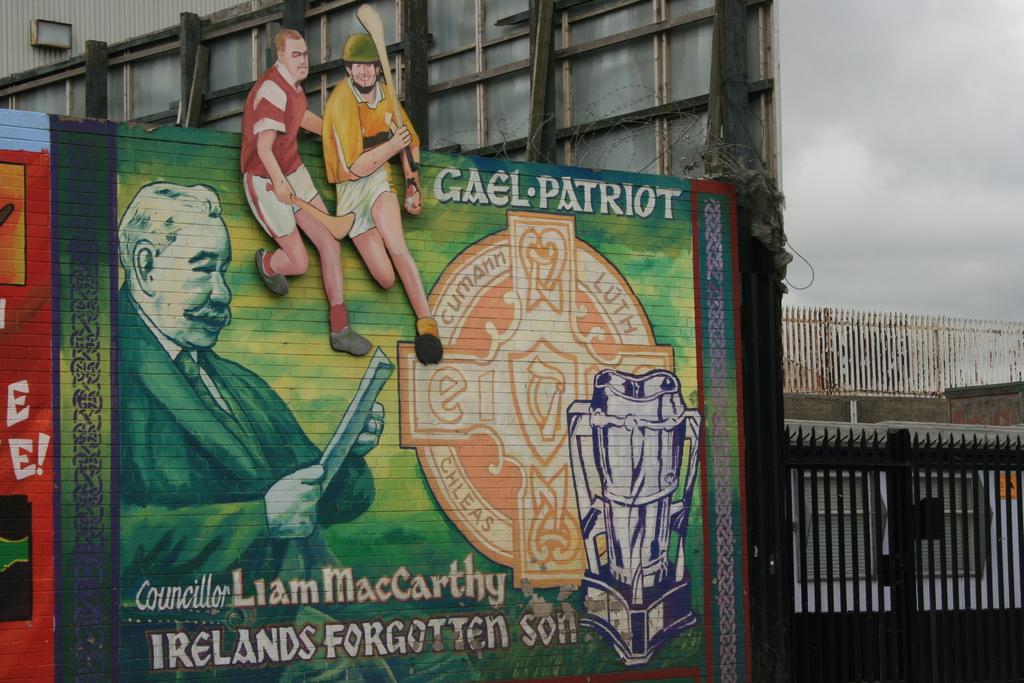What is that ad promoting?
Provide a succinct answer. Unanswerable. Is liam maccarthy irelands' forgotten son?
Your answer should be compact. Yes. 